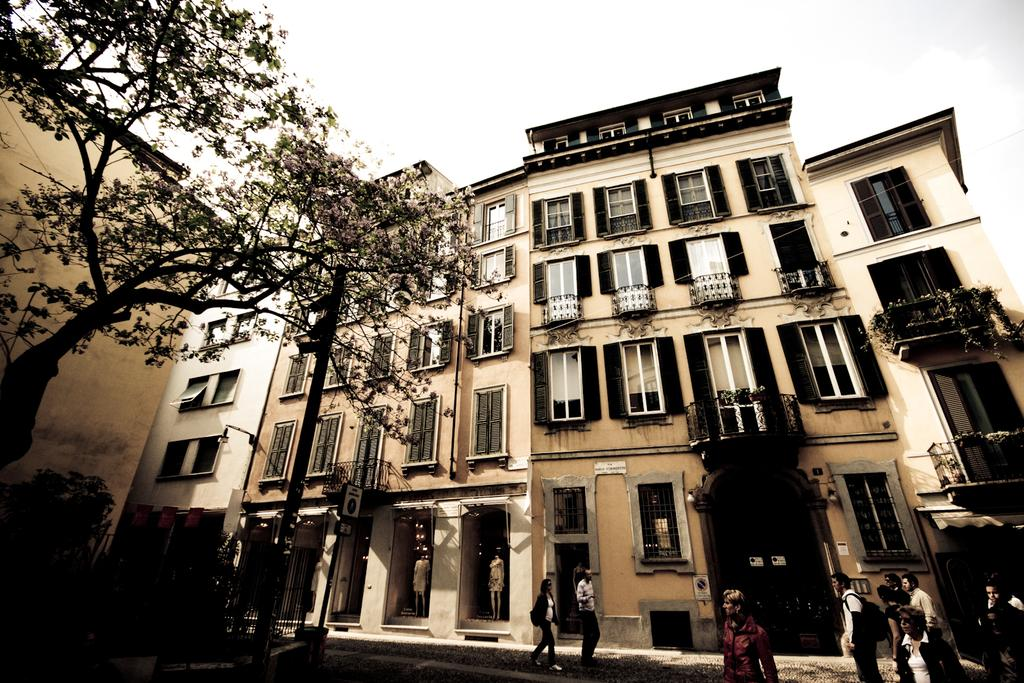What type of structures are present in the image? There are buildings with windows in the image. Where is the tree located in the image? The tree is on the left side of the image. Can you describe the people visible in the image? There are persons visible in the image. What is visible at the top of the image? The sky is visible at the top of the image. Where is the vase located in the image? There is no vase present in the image. What type of cemetery can be seen in the image? There is no cemetery present in the image. 